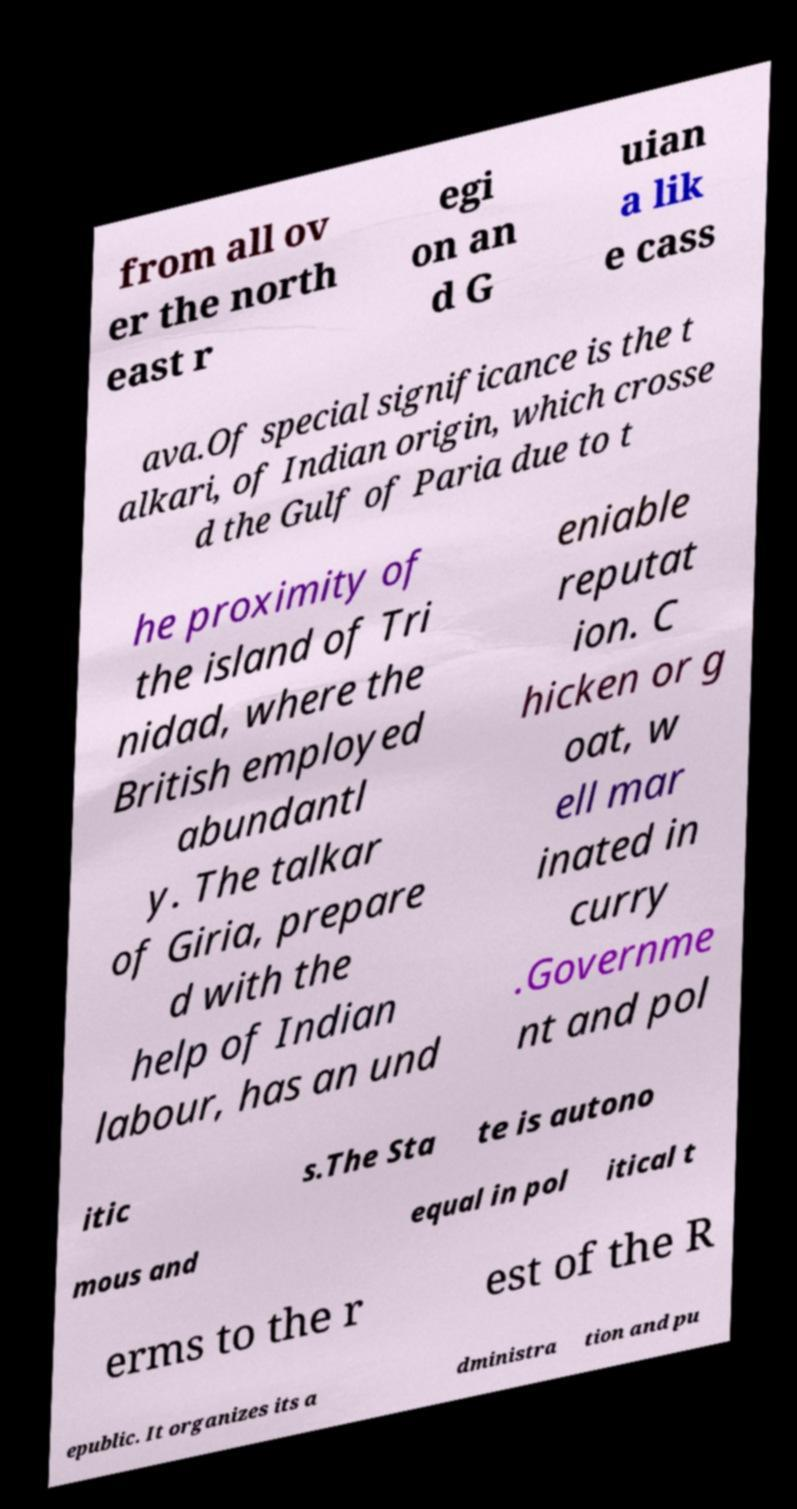Can you accurately transcribe the text from the provided image for me? from all ov er the north east r egi on an d G uian a lik e cass ava.Of special significance is the t alkari, of Indian origin, which crosse d the Gulf of Paria due to t he proximity of the island of Tri nidad, where the British employed abundantl y. The talkar of Giria, prepare d with the help of Indian labour, has an und eniable reputat ion. C hicken or g oat, w ell mar inated in curry .Governme nt and pol itic s.The Sta te is autono mous and equal in pol itical t erms to the r est of the R epublic. It organizes its a dministra tion and pu 